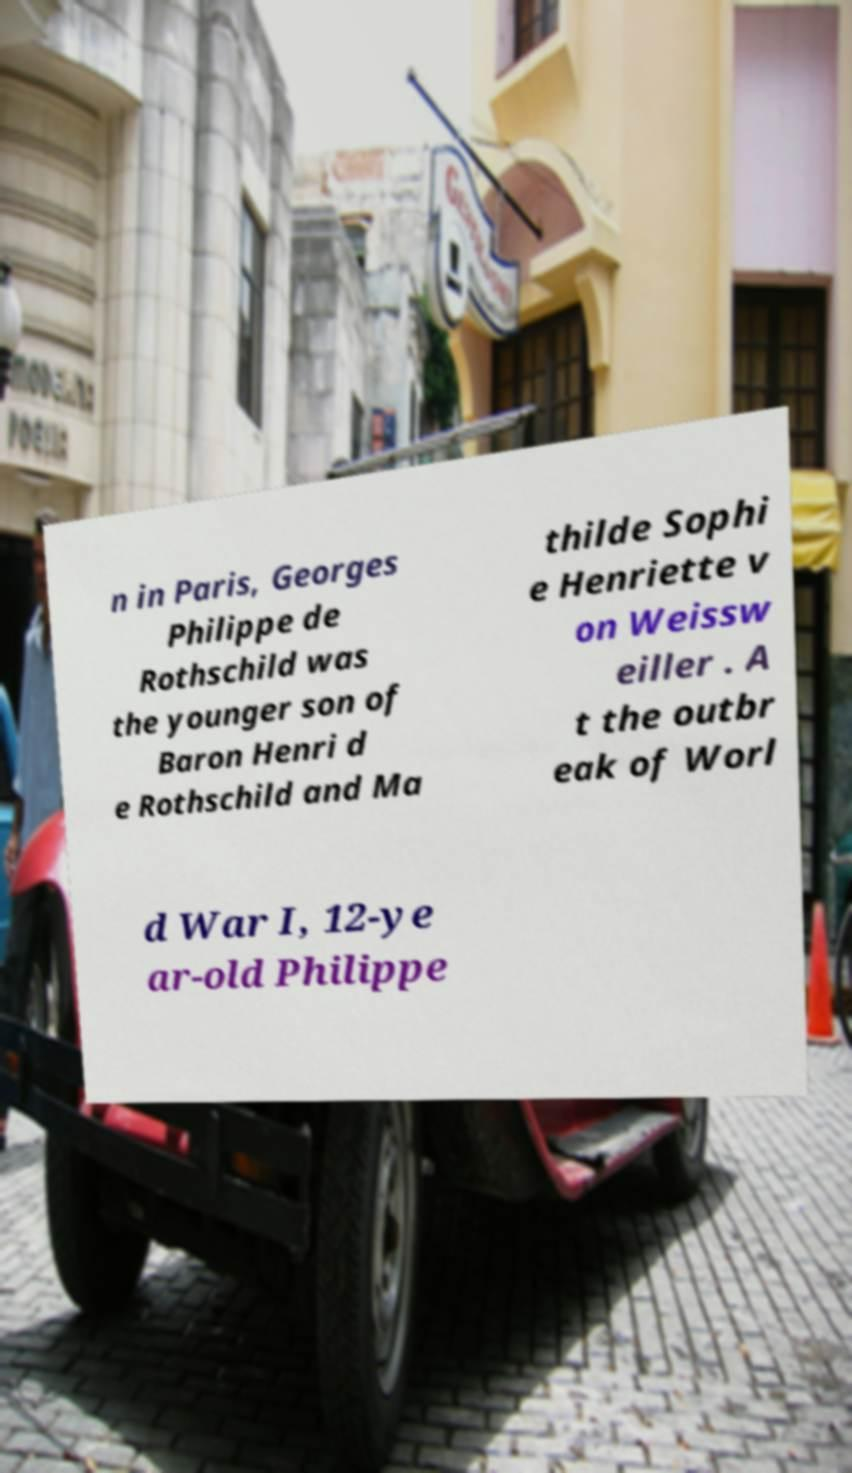Could you extract and type out the text from this image? n in Paris, Georges Philippe de Rothschild was the younger son of Baron Henri d e Rothschild and Ma thilde Sophi e Henriette v on Weissw eiller . A t the outbr eak of Worl d War I, 12-ye ar-old Philippe 